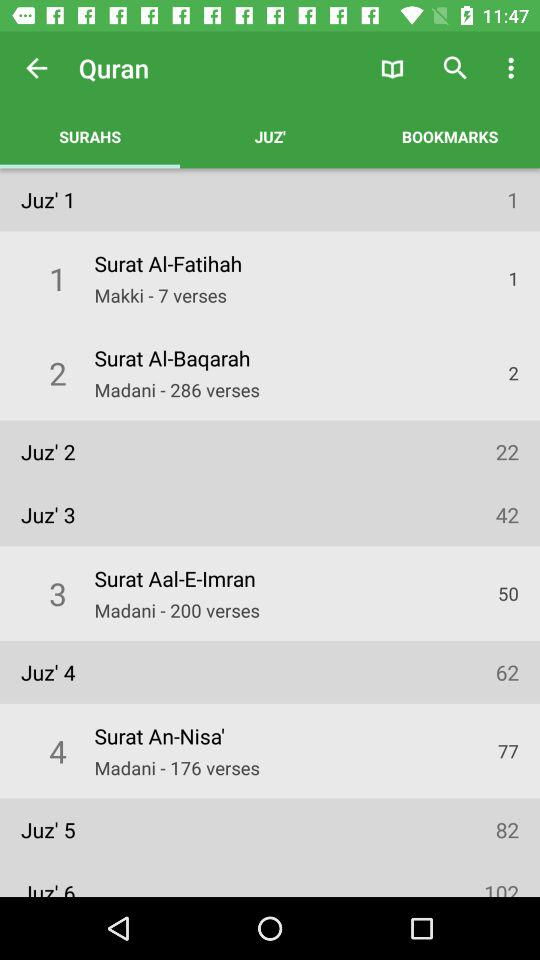How many verses are there in "Surat Al-Baqarah"? There are 286 verses in "Surat Al-Baqarah". 